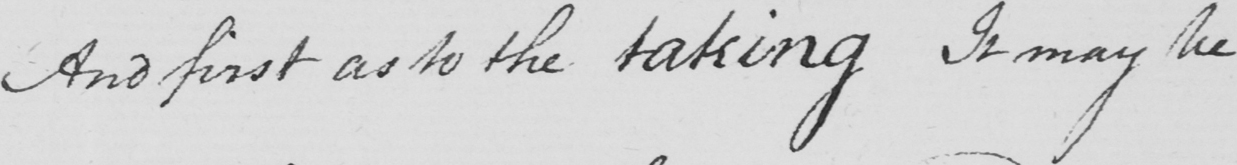Transcribe the text shown in this historical manuscript line. And first as to the taking It may be 